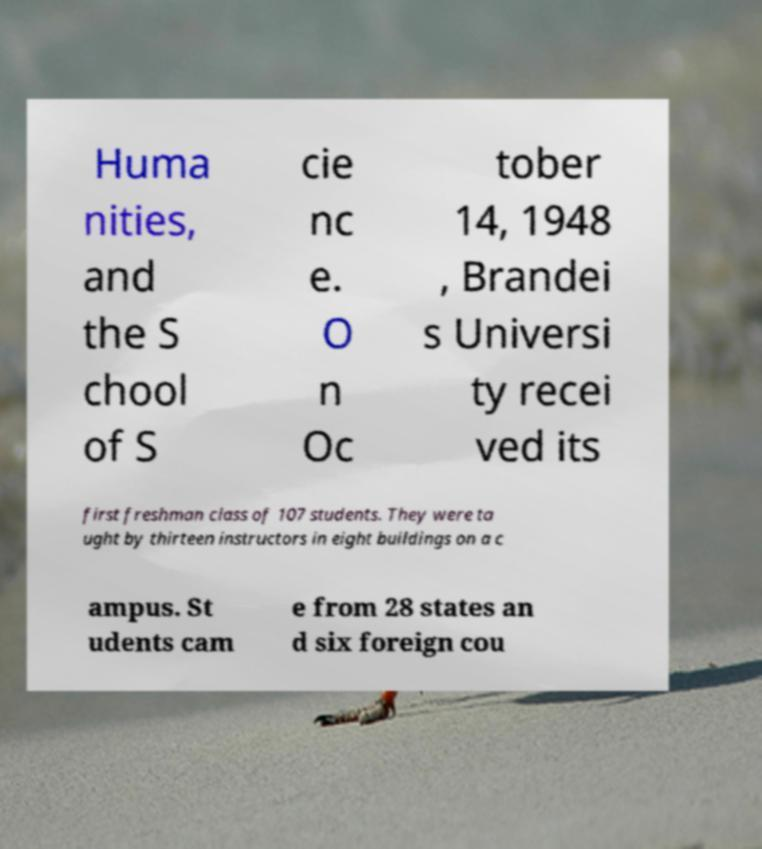Could you assist in decoding the text presented in this image and type it out clearly? Huma nities, and the S chool of S cie nc e. O n Oc tober 14, 1948 , Brandei s Universi ty recei ved its first freshman class of 107 students. They were ta ught by thirteen instructors in eight buildings on a c ampus. St udents cam e from 28 states an d six foreign cou 